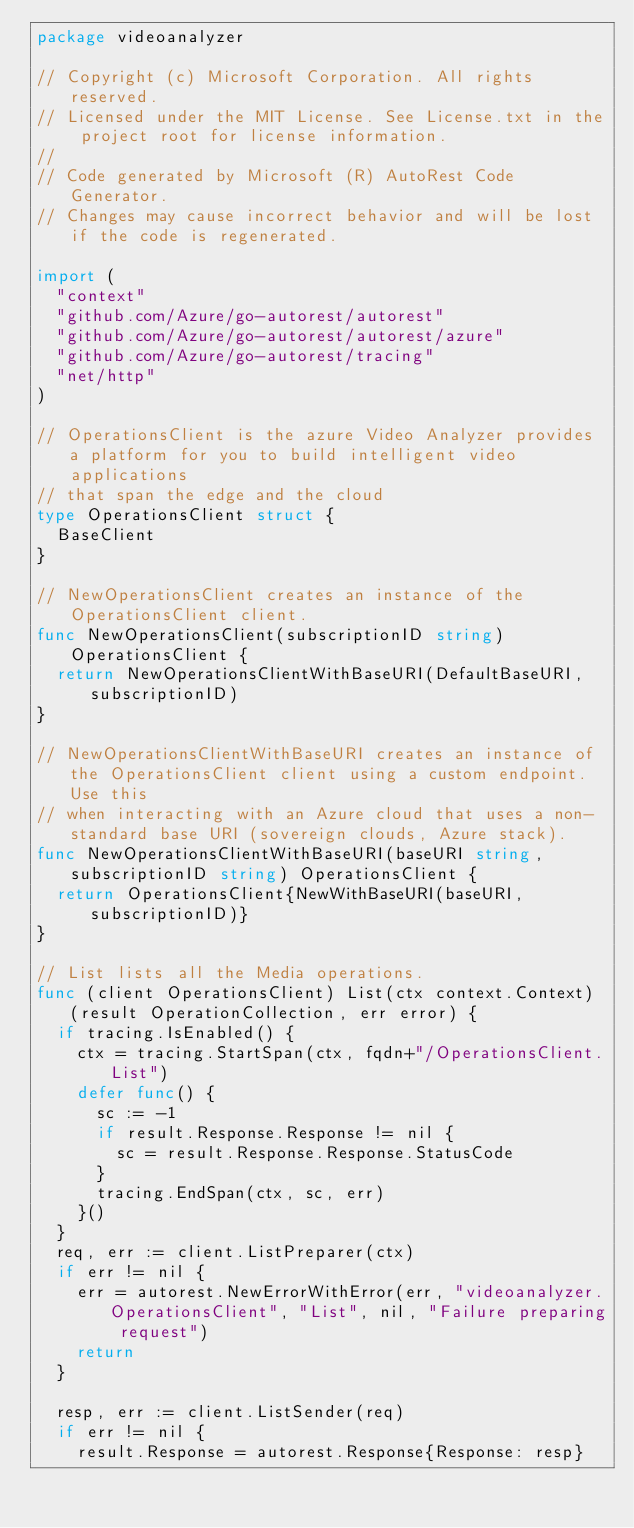<code> <loc_0><loc_0><loc_500><loc_500><_Go_>package videoanalyzer

// Copyright (c) Microsoft Corporation. All rights reserved.
// Licensed under the MIT License. See License.txt in the project root for license information.
//
// Code generated by Microsoft (R) AutoRest Code Generator.
// Changes may cause incorrect behavior and will be lost if the code is regenerated.

import (
	"context"
	"github.com/Azure/go-autorest/autorest"
	"github.com/Azure/go-autorest/autorest/azure"
	"github.com/Azure/go-autorest/tracing"
	"net/http"
)

// OperationsClient is the azure Video Analyzer provides a platform for you to build intelligent video applications
// that span the edge and the cloud
type OperationsClient struct {
	BaseClient
}

// NewOperationsClient creates an instance of the OperationsClient client.
func NewOperationsClient(subscriptionID string) OperationsClient {
	return NewOperationsClientWithBaseURI(DefaultBaseURI, subscriptionID)
}

// NewOperationsClientWithBaseURI creates an instance of the OperationsClient client using a custom endpoint.  Use this
// when interacting with an Azure cloud that uses a non-standard base URI (sovereign clouds, Azure stack).
func NewOperationsClientWithBaseURI(baseURI string, subscriptionID string) OperationsClient {
	return OperationsClient{NewWithBaseURI(baseURI, subscriptionID)}
}

// List lists all the Media operations.
func (client OperationsClient) List(ctx context.Context) (result OperationCollection, err error) {
	if tracing.IsEnabled() {
		ctx = tracing.StartSpan(ctx, fqdn+"/OperationsClient.List")
		defer func() {
			sc := -1
			if result.Response.Response != nil {
				sc = result.Response.Response.StatusCode
			}
			tracing.EndSpan(ctx, sc, err)
		}()
	}
	req, err := client.ListPreparer(ctx)
	if err != nil {
		err = autorest.NewErrorWithError(err, "videoanalyzer.OperationsClient", "List", nil, "Failure preparing request")
		return
	}

	resp, err := client.ListSender(req)
	if err != nil {
		result.Response = autorest.Response{Response: resp}</code> 